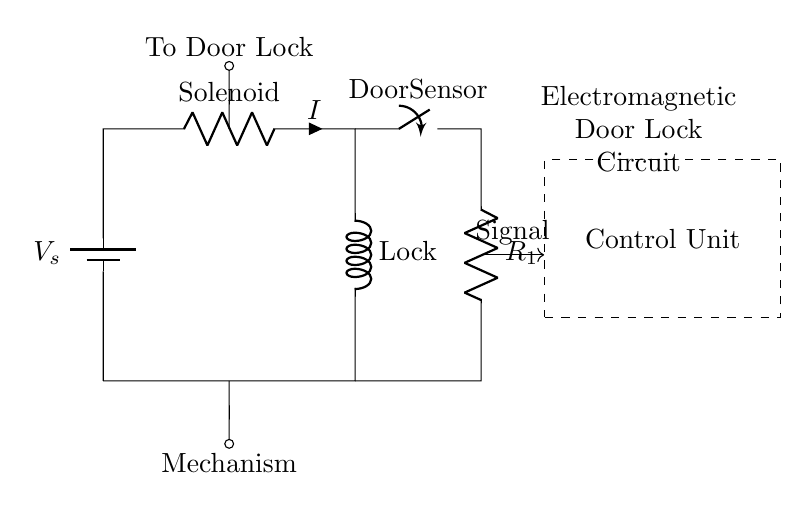What is the type of the first component in the circuit? The first component is a battery, as indicated at the top left corner of the circuit diagram.
Answer: Battery What component is represented by the label "Lock"? "Lock" refers to the inductor component in the circuit, specifically the solenoid that secures the door lock when energized.
Answer: Inductor What does the "Door Sensor" switch control? The "Door Sensor" switch controls the flow of current to the circuit, enabling or disabling the electromagnetic door lock based on whether the door is open or closed.
Answer: Current flow What is the role of the resistor labeled "R1"? The resistor R1 helps to limit the current flowing through the lock, thereby preventing excessive current that could damage the circuit components, especially the solenoid.
Answer: Current limiting How many main components are in this circuit? The circuit contains a battery, a resistor, an inductor, and a switch, totaling four main components as seen in the diagram.
Answer: Four What happens when the "Door Sensor" switch is closed? When the switch is closed, it completes the circuit, allowing current to flow through the solenoid, which activates the lock mechanism securely.
Answer: Activates lock 